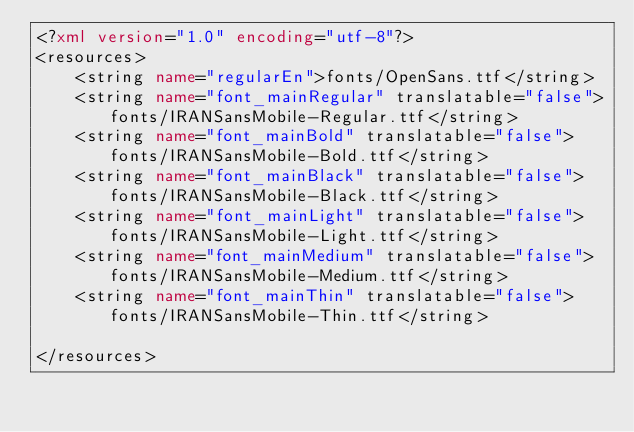Convert code to text. <code><loc_0><loc_0><loc_500><loc_500><_XML_><?xml version="1.0" encoding="utf-8"?>
<resources>
    <string name="regularEn">fonts/OpenSans.ttf</string>
    <string name="font_mainRegular" translatable="false">fonts/IRANSansMobile-Regular.ttf</string>
    <string name="font_mainBold" translatable="false">fonts/IRANSansMobile-Bold.ttf</string>
    <string name="font_mainBlack" translatable="false">fonts/IRANSansMobile-Black.ttf</string>
    <string name="font_mainLight" translatable="false">fonts/IRANSansMobile-Light.ttf</string>
    <string name="font_mainMedium" translatable="false">fonts/IRANSansMobile-Medium.ttf</string>
    <string name="font_mainThin" translatable="false">fonts/IRANSansMobile-Thin.ttf</string>

</resources></code> 